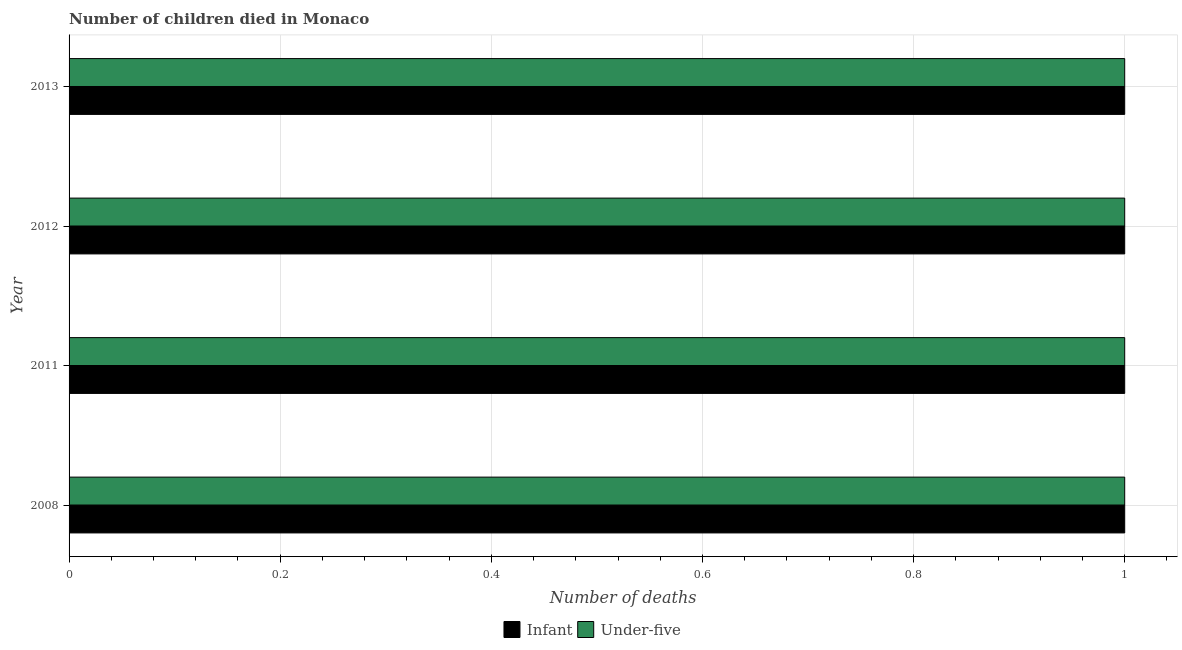How many different coloured bars are there?
Provide a short and direct response. 2. How many bars are there on the 2nd tick from the top?
Make the answer very short. 2. What is the label of the 2nd group of bars from the top?
Give a very brief answer. 2012. What is the number of infant deaths in 2011?
Make the answer very short. 1. Across all years, what is the maximum number of under-five deaths?
Offer a very short reply. 1. Across all years, what is the minimum number of under-five deaths?
Keep it short and to the point. 1. In which year was the number of infant deaths maximum?
Ensure brevity in your answer.  2008. What is the total number of infant deaths in the graph?
Offer a terse response. 4. What is the difference between the number of infant deaths in 2008 and the number of under-five deaths in 2011?
Keep it short and to the point. 0. What is the average number of under-five deaths per year?
Provide a short and direct response. 1. In how many years, is the number of under-five deaths greater than 0.7200000000000001 ?
Provide a short and direct response. 4. What is the ratio of the number of under-five deaths in 2008 to that in 2013?
Make the answer very short. 1. Is the difference between the number of infant deaths in 2012 and 2013 greater than the difference between the number of under-five deaths in 2012 and 2013?
Your answer should be very brief. No. In how many years, is the number of under-five deaths greater than the average number of under-five deaths taken over all years?
Provide a short and direct response. 0. Is the sum of the number of infant deaths in 2008 and 2012 greater than the maximum number of under-five deaths across all years?
Provide a succinct answer. Yes. What does the 2nd bar from the top in 2012 represents?
Keep it short and to the point. Infant. What does the 1st bar from the bottom in 2011 represents?
Offer a very short reply. Infant. How many bars are there?
Make the answer very short. 8. Are all the bars in the graph horizontal?
Your answer should be compact. Yes. How many years are there in the graph?
Provide a short and direct response. 4. Are the values on the major ticks of X-axis written in scientific E-notation?
Your response must be concise. No. Does the graph contain any zero values?
Make the answer very short. No. Does the graph contain grids?
Your answer should be very brief. Yes. Where does the legend appear in the graph?
Offer a very short reply. Bottom center. What is the title of the graph?
Offer a very short reply. Number of children died in Monaco. Does "Secondary Education" appear as one of the legend labels in the graph?
Provide a succinct answer. No. What is the label or title of the X-axis?
Ensure brevity in your answer.  Number of deaths. What is the label or title of the Y-axis?
Keep it short and to the point. Year. What is the Number of deaths in Infant in 2008?
Your answer should be compact. 1. What is the Number of deaths of Under-five in 2011?
Ensure brevity in your answer.  1. What is the Number of deaths of Infant in 2012?
Offer a very short reply. 1. What is the Number of deaths in Infant in 2013?
Ensure brevity in your answer.  1. What is the total Number of deaths of Infant in the graph?
Provide a succinct answer. 4. What is the difference between the Number of deaths of Infant in 2008 and that in 2012?
Offer a very short reply. 0. What is the difference between the Number of deaths of Infant in 2012 and that in 2013?
Your answer should be compact. 0. What is the difference between the Number of deaths of Under-five in 2012 and that in 2013?
Your answer should be compact. 0. What is the difference between the Number of deaths of Infant in 2012 and the Number of deaths of Under-five in 2013?
Your answer should be very brief. 0. What is the average Number of deaths of Infant per year?
Your answer should be very brief. 1. In the year 2008, what is the difference between the Number of deaths of Infant and Number of deaths of Under-five?
Offer a very short reply. 0. In the year 2011, what is the difference between the Number of deaths in Infant and Number of deaths in Under-five?
Keep it short and to the point. 0. In the year 2013, what is the difference between the Number of deaths of Infant and Number of deaths of Under-five?
Give a very brief answer. 0. What is the ratio of the Number of deaths of Infant in 2008 to that in 2011?
Your response must be concise. 1. What is the ratio of the Number of deaths in Under-five in 2008 to that in 2011?
Your answer should be compact. 1. What is the ratio of the Number of deaths of Infant in 2008 to that in 2012?
Give a very brief answer. 1. What is the ratio of the Number of deaths of Infant in 2008 to that in 2013?
Your response must be concise. 1. What is the ratio of the Number of deaths in Under-five in 2011 to that in 2012?
Your response must be concise. 1. What is the ratio of the Number of deaths of Infant in 2011 to that in 2013?
Make the answer very short. 1. What is the difference between the highest and the lowest Number of deaths of Under-five?
Keep it short and to the point. 0. 